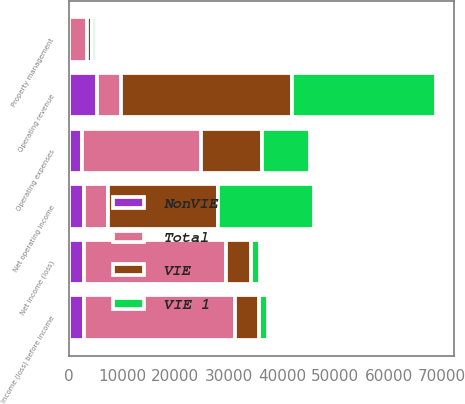Convert chart to OTSL. <chart><loc_0><loc_0><loc_500><loc_500><stacked_bar_chart><ecel><fcel>Operating revenue<fcel>Operating expenses<fcel>Net operating income<fcel>Property management<fcel>Income (loss) before income<fcel>Net income (loss)<nl><fcel>Total<fcel>4550.5<fcel>22412<fcel>4550.5<fcel>3401<fcel>28366<fcel>26790<nl><fcel>VIE 1<fcel>26898<fcel>8936<fcel>17962<fcel>784<fcel>1748<fcel>1761<nl><fcel>NonVIE<fcel>5243<fcel>2463<fcel>2780<fcel>75<fcel>2796<fcel>2796<nl><fcel>VIE<fcel>32141<fcel>11399<fcel>20742<fcel>859<fcel>4544<fcel>4557<nl></chart> 